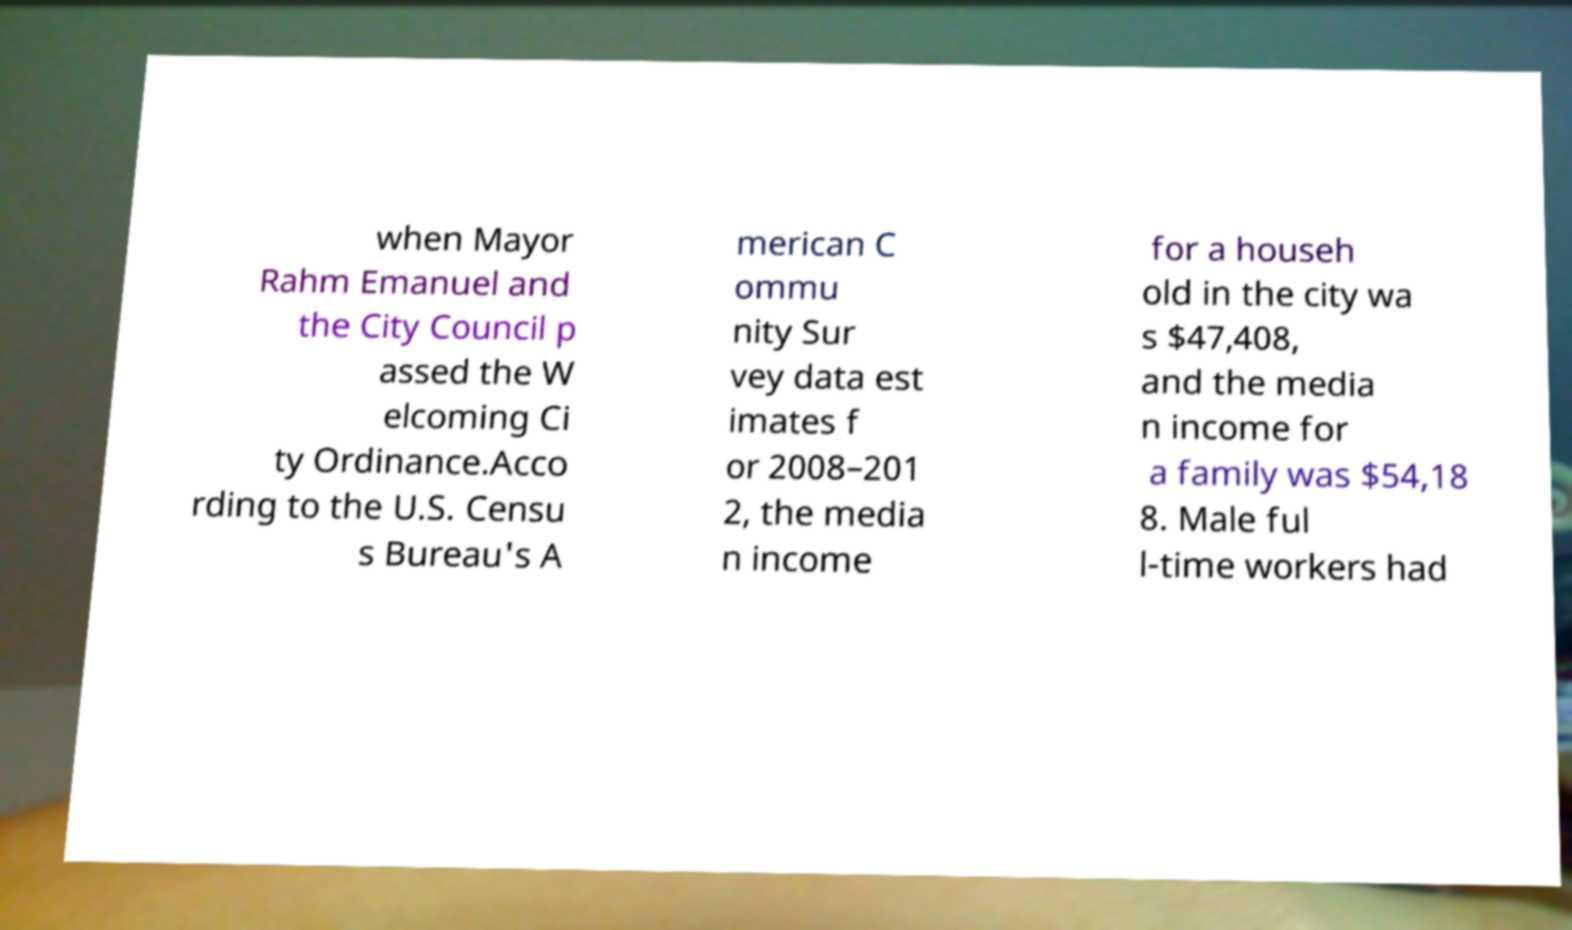For documentation purposes, I need the text within this image transcribed. Could you provide that? when Mayor Rahm Emanuel and the City Council p assed the W elcoming Ci ty Ordinance.Acco rding to the U.S. Censu s Bureau's A merican C ommu nity Sur vey data est imates f or 2008–201 2, the media n income for a househ old in the city wa s $47,408, and the media n income for a family was $54,18 8. Male ful l-time workers had 